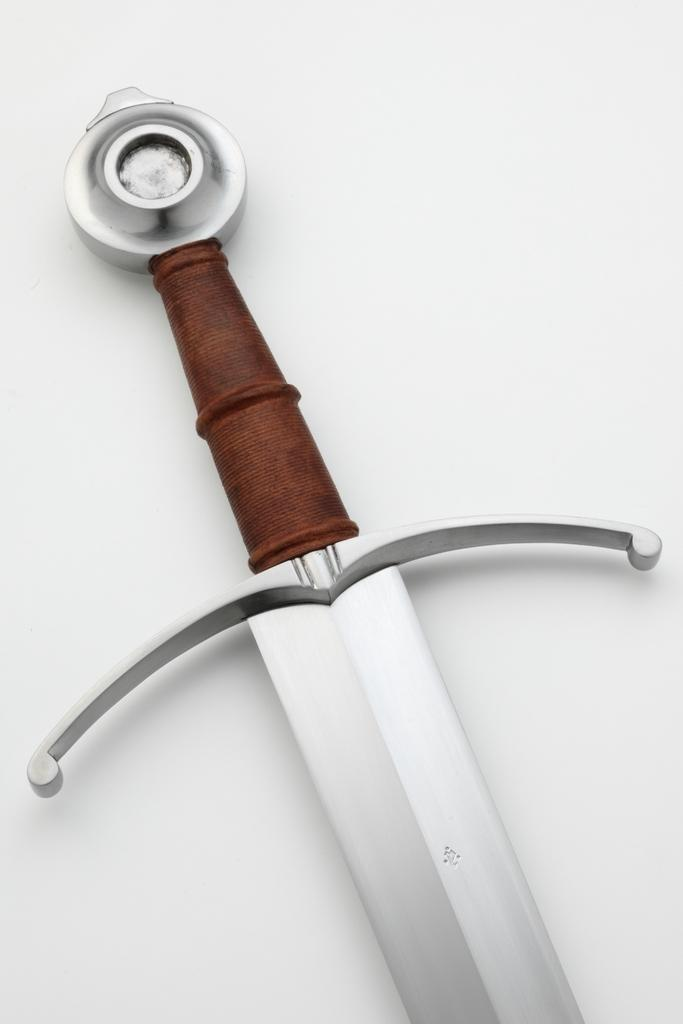What is the main object in the image? There is a sword in the image. What is the sword placed on? The sword is on a white platform. What can be said about the handle of the sword? The handle of the sword is brown in color. How many frogs are sitting on the sword in the image? There are no frogs present in the image; it only features a sword on a white platform. 